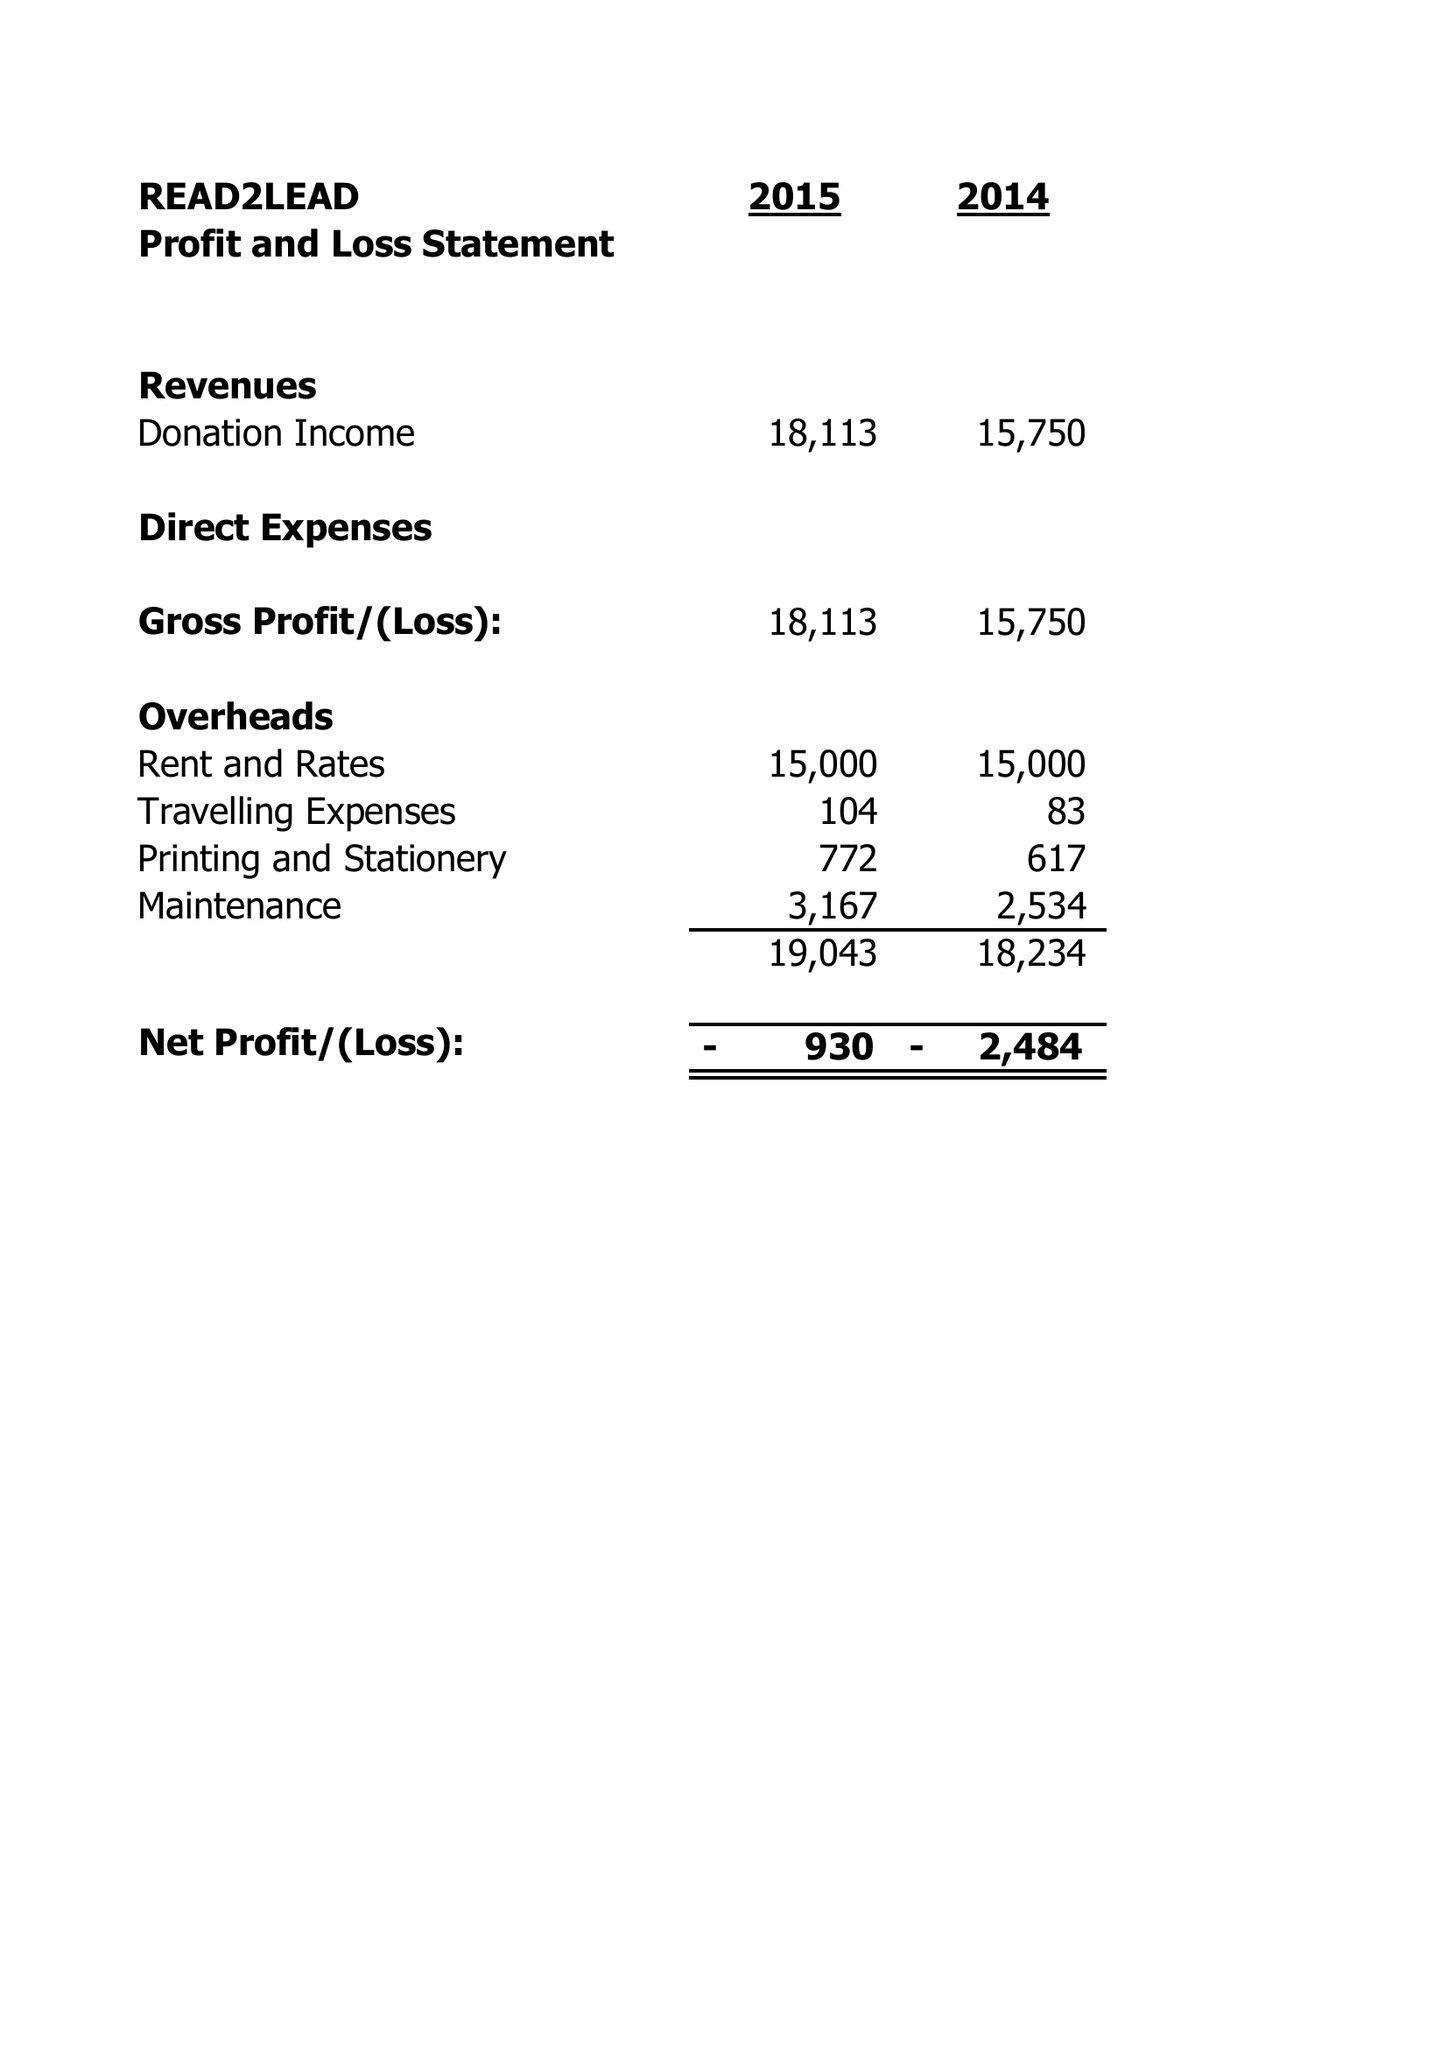What is the value for the report_date?
Answer the question using a single word or phrase. 2015-03-31 